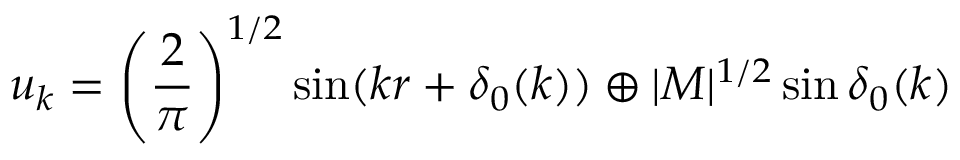Convert formula to latex. <formula><loc_0><loc_0><loc_500><loc_500>u _ { k } = \left ( \frac { 2 } { \pi } \right ) ^ { 1 / 2 } \sin ( k r + \delta _ { 0 } ( k ) ) \oplus | M | ^ { 1 / 2 } \sin \delta _ { 0 } ( k )</formula> 